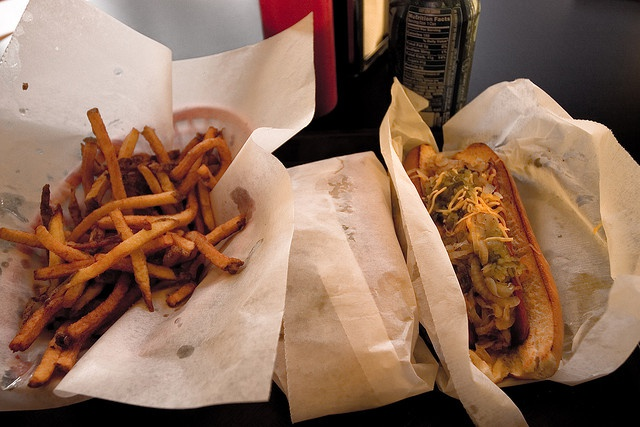Describe the objects in this image and their specific colors. I can see sandwich in brown, maroon, and black tones, hot dog in brown, maroon, and black tones, and bottle in brown, black, and gray tones in this image. 